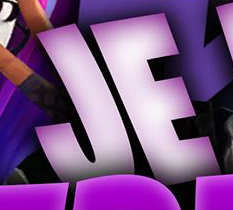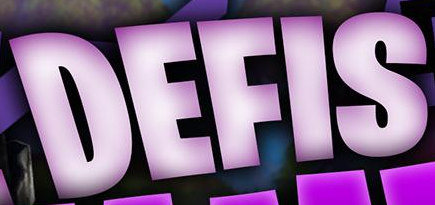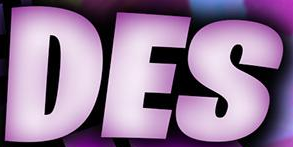Read the text from these images in sequence, separated by a semicolon. JE; DEFIS; DES 